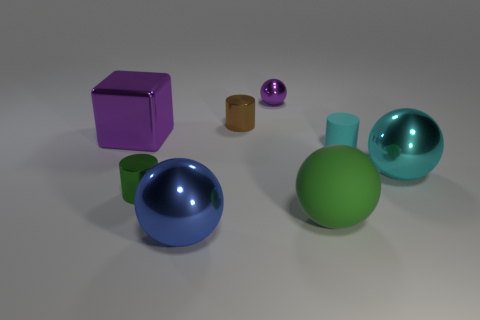Subtract all cyan metal balls. How many balls are left? 3 Add 1 large shiny cylinders. How many objects exist? 9 Subtract 2 cylinders. How many cylinders are left? 1 Subtract all cyan cylinders. How many cylinders are left? 2 Add 3 green spheres. How many green spheres exist? 4 Subtract 0 gray balls. How many objects are left? 8 Subtract all cylinders. How many objects are left? 5 Subtract all green balls. Subtract all red blocks. How many balls are left? 3 Subtract all purple cubes. How many cyan cylinders are left? 1 Subtract all spheres. Subtract all rubber cylinders. How many objects are left? 3 